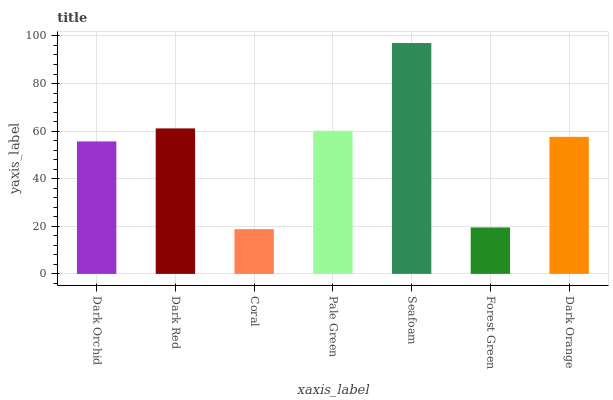Is Dark Red the minimum?
Answer yes or no. No. Is Dark Red the maximum?
Answer yes or no. No. Is Dark Red greater than Dark Orchid?
Answer yes or no. Yes. Is Dark Orchid less than Dark Red?
Answer yes or no. Yes. Is Dark Orchid greater than Dark Red?
Answer yes or no. No. Is Dark Red less than Dark Orchid?
Answer yes or no. No. Is Dark Orange the high median?
Answer yes or no. Yes. Is Dark Orange the low median?
Answer yes or no. Yes. Is Pale Green the high median?
Answer yes or no. No. Is Coral the low median?
Answer yes or no. No. 